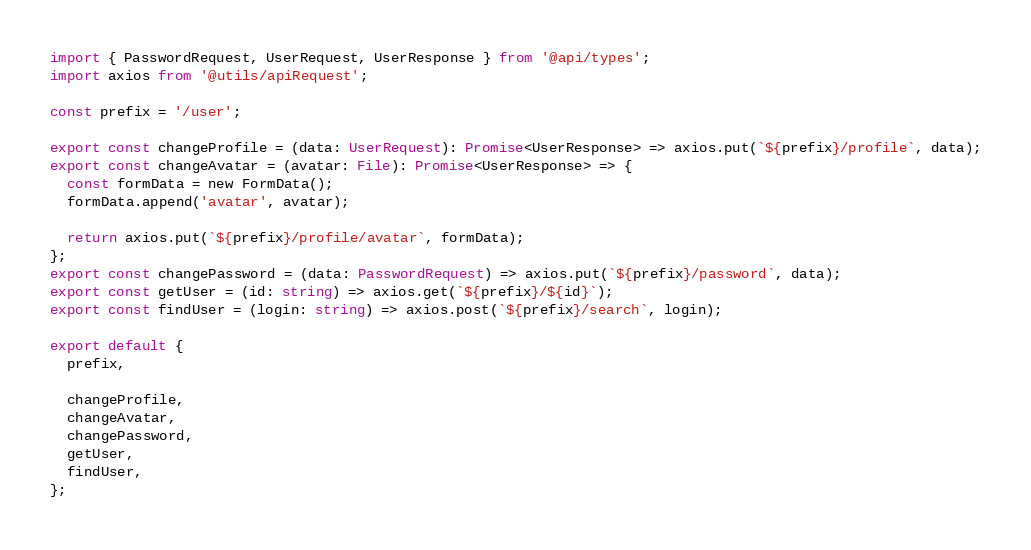<code> <loc_0><loc_0><loc_500><loc_500><_TypeScript_>import { PasswordRequest, UserRequest, UserResponse } from '@api/types';
import axios from '@utils/apiRequest';

const prefix = '/user';

export const changeProfile = (data: UserRequest): Promise<UserResponse> => axios.put(`${prefix}/profile`, data);
export const changeAvatar = (avatar: File): Promise<UserResponse> => {
  const formData = new FormData();
  formData.append('avatar', avatar);

  return axios.put(`${prefix}/profile/avatar`, formData);
};
export const changePassword = (data: PasswordRequest) => axios.put(`${prefix}/password`, data);
export const getUser = (id: string) => axios.get(`${prefix}/${id}`);
export const findUser = (login: string) => axios.post(`${prefix}/search`, login);

export default {
  prefix,

  changeProfile,
  changeAvatar,
  changePassword,
  getUser,
  findUser,
};
</code> 